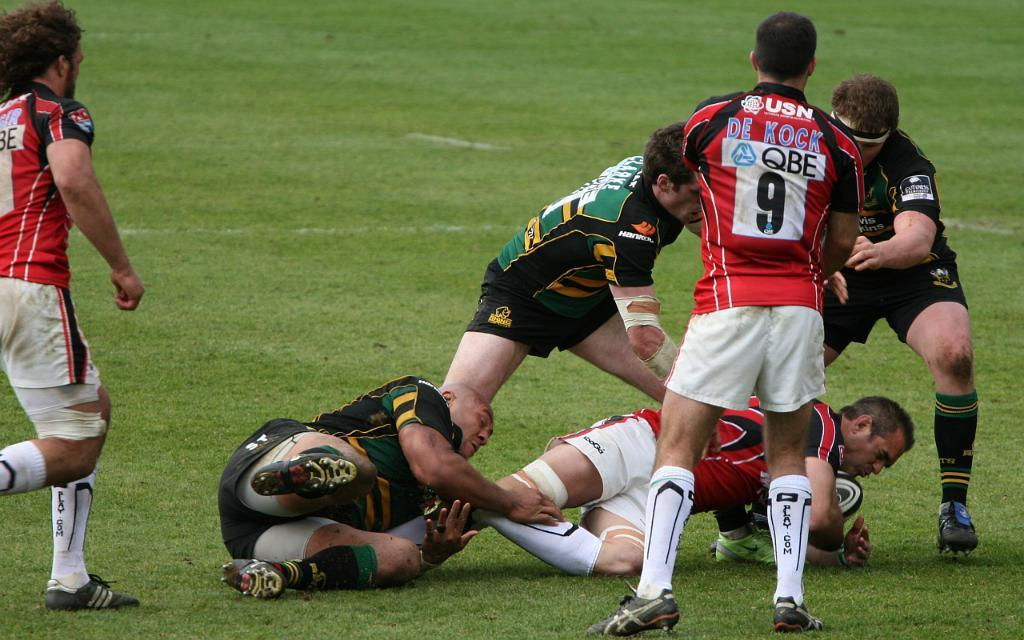Who or what can be seen in the image? There are people in the image. What is the terrain like in the image? The land is covered with grass. What object is being held by one of the people in the image? One person is holding a ball. What type of list can be seen in the image? There is no list present in the image. Can you describe the quiver that is being used by one of the people in the image? There is no quiver present in the image. 